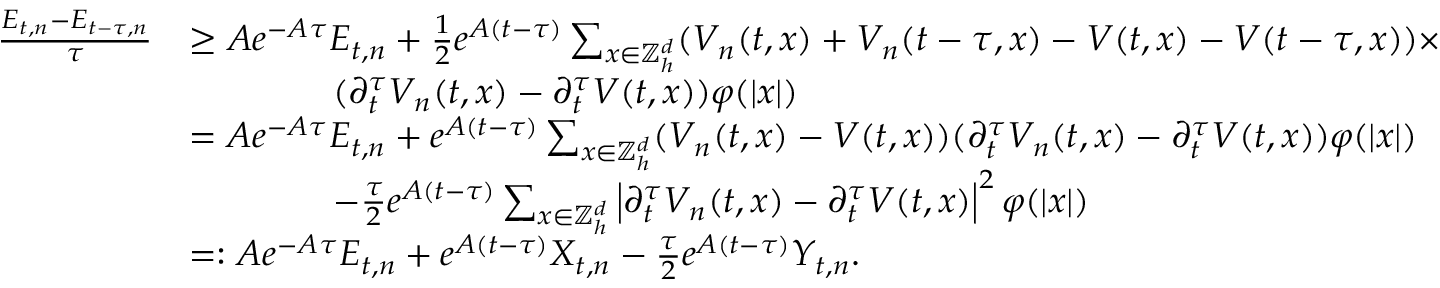Convert formula to latex. <formula><loc_0><loc_0><loc_500><loc_500>\begin{array} { r l } { \frac { E _ { t , n } - E _ { t - \tau , n } } \tau } & { \geq A e ^ { - A \tau } E _ { t , n } + \frac { 1 } { 2 } e ^ { A ( t - \tau ) } \sum _ { x \in { \mathbb { Z } } _ { h } ^ { d } } ( V _ { n } ( t , x ) + V _ { n } ( t - \tau , x ) - V ( t , x ) - V ( t - \tau , x ) ) \times } \\ & { \quad ( \partial _ { t } ^ { \tau } V _ { n } ( t , x ) - \partial _ { t } ^ { \tau } V ( t , x ) ) \varphi ( | x | ) } \\ & { = A e ^ { - A \tau } E _ { t , n } + e ^ { A ( t - \tau ) } \sum _ { x \in { \mathbb { Z } } _ { h } ^ { d } } ( V _ { n } ( t , x ) - V ( t , x ) ) ( \partial _ { t } ^ { \tau } V _ { n } ( t , x ) - \partial _ { t } ^ { \tau } V ( t , x ) ) \varphi ( | x | ) } \\ & { \quad - \frac { \tau } 2 e ^ { A ( t - \tau ) } \sum _ { x \in { \mathbb { Z } } _ { h } ^ { d } } \left | \partial _ { t } ^ { \tau } V _ { n } ( t , x ) - \partial _ { t } ^ { \tau } V ( t , x ) \right | ^ { 2 } \varphi ( | x | ) } \\ & { = \colon A e ^ { - A \tau } E _ { t , n } + e ^ { A ( t - \tau ) } X _ { t , n } - \frac { \tau } 2 e ^ { A ( t - \tau ) } Y _ { t , n } . } \end{array}</formula> 